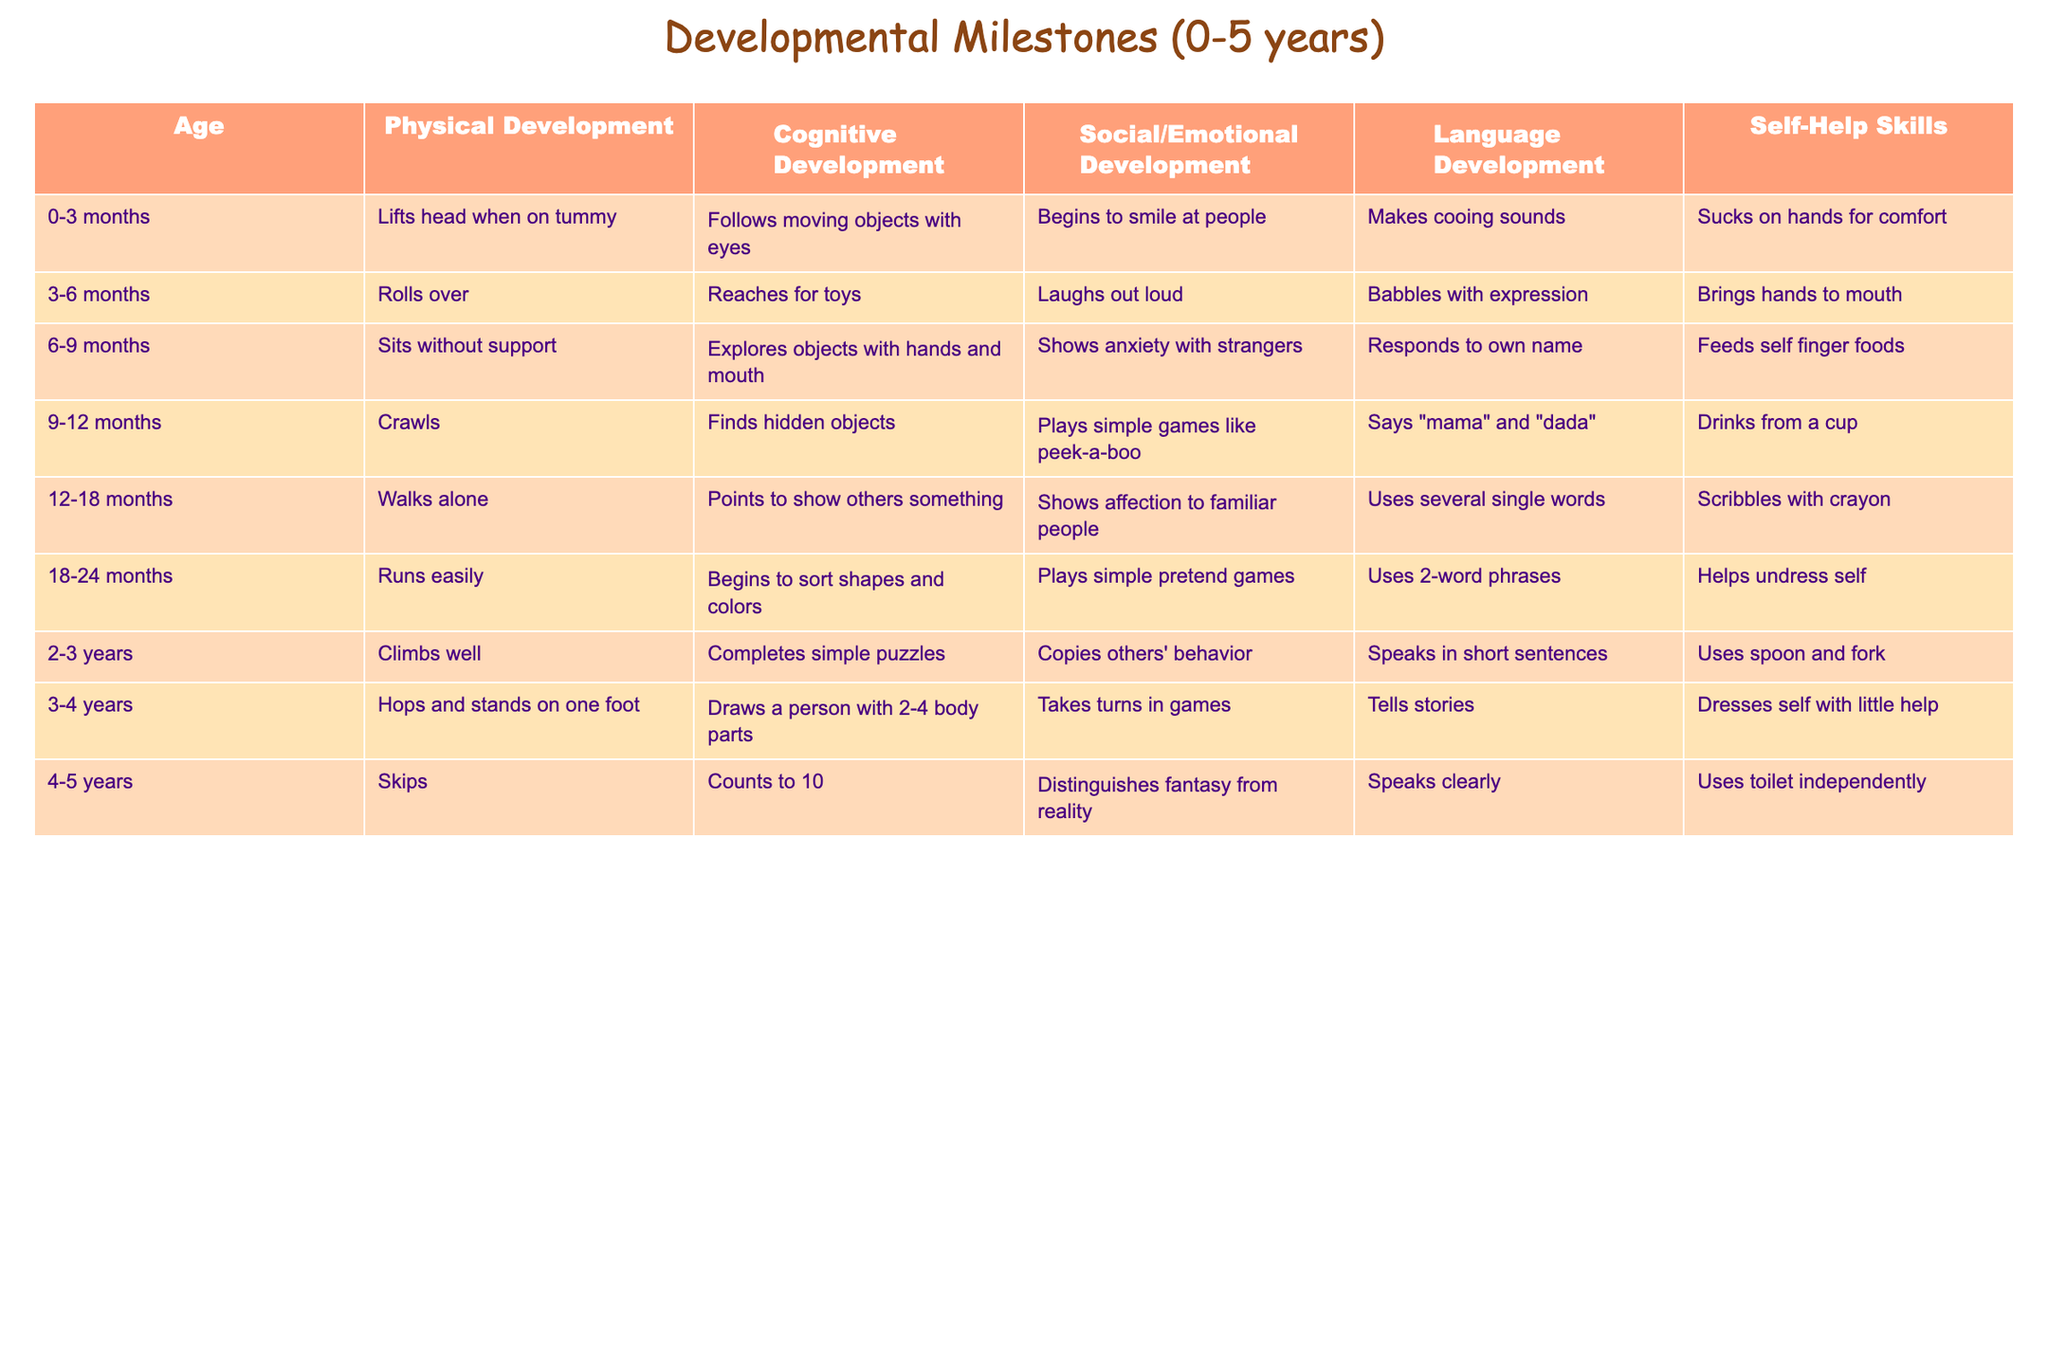What is the physical development milestone for children aged 0-3 months? The table indicates that for children aged 0-3 months, the milestone is "Lifts head when on tummy."
Answer: Lifts head when on tummy What language development milestone is reached by children aged 18-24 months? According to the table, children aged 18-24 months use 2-word phrases as their language development milestone.
Answer: Uses 2-word phrases At what age do children typically start to walk alone? Referring to the table, children typically walk alone at the age of 12-18 months.
Answer: 12-18 months Which age group shows the ability to sort shapes and colors? The table shows that children aged 18-24 months begin to sort shapes and colors.
Answer: 18-24 months Is it true that children aged 4-5 years can count to 10? Yes, the table confirms that children aged 4-5 years can count to 10.
Answer: Yes How many self-help skills milestones are listed for children aged 3-4 years? The table indicates that children aged 3-4 years have one listed self-help skill milestone: "Dresses self with little help."
Answer: 1 Which developmental area shows that children aged 6-9 months sit without support? The table indicates that the physical development area shows the milestone "Sits without support" for children aged 6-9 months.
Answer: Physical development What is the average number of language development milestones for children aged 0-5 years? There are 5 age groups and each age group has 1 language development milestone, totaling 5 milestones. The average is 5/5 = 1.
Answer: 1 Which age group has the most comprehensive development in social/emotional skills based on the provided milestones? By examining the social/emotional milestone entries, children aged 3-4 years have the most comprehensive skills with "Takes turns in games" and "Tells stories".
Answer: 3-4 years Compare the physical development milestones between ages 2-3 years and 3-4 years. At ages 2-3 years, children can "Climb well" while at 3-4 years, children "Hops and stands on one foot," which indicates increasing physical capabilities.
Answer: Increasing capabilities 